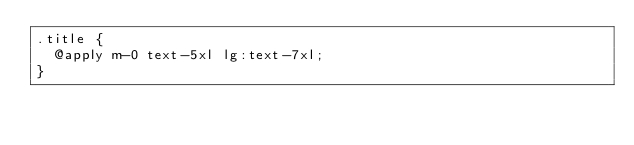Convert code to text. <code><loc_0><loc_0><loc_500><loc_500><_CSS_>.title {
  @apply m-0 text-5xl lg:text-7xl;
}
</code> 